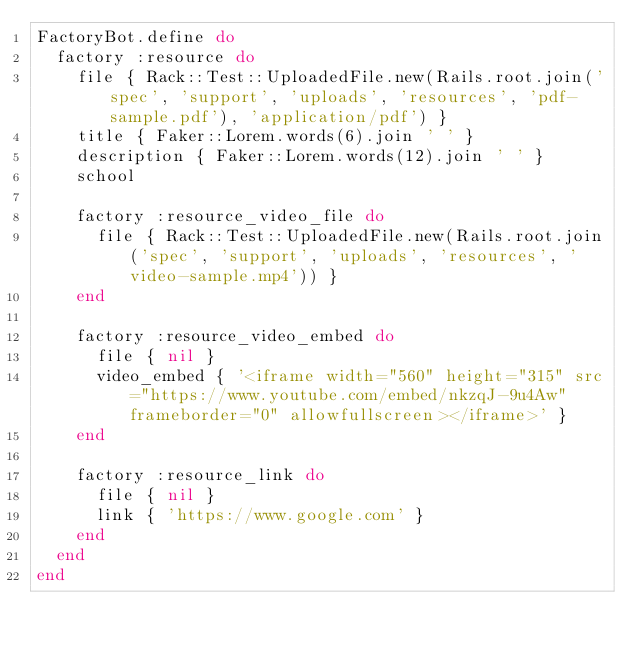<code> <loc_0><loc_0><loc_500><loc_500><_Ruby_>FactoryBot.define do
  factory :resource do
    file { Rack::Test::UploadedFile.new(Rails.root.join('spec', 'support', 'uploads', 'resources', 'pdf-sample.pdf'), 'application/pdf') }
    title { Faker::Lorem.words(6).join ' ' }
    description { Faker::Lorem.words(12).join ' ' }
    school

    factory :resource_video_file do
      file { Rack::Test::UploadedFile.new(Rails.root.join('spec', 'support', 'uploads', 'resources', 'video-sample.mp4')) }
    end

    factory :resource_video_embed do
      file { nil }
      video_embed { '<iframe width="560" height="315" src="https://www.youtube.com/embed/nkzqJ-9u4Aw" frameborder="0" allowfullscreen></iframe>' }
    end

    factory :resource_link do
      file { nil }
      link { 'https://www.google.com' }
    end
  end
end
</code> 